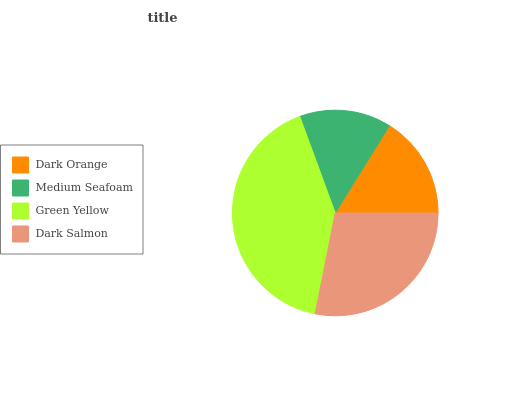Is Medium Seafoam the minimum?
Answer yes or no. Yes. Is Green Yellow the maximum?
Answer yes or no. Yes. Is Green Yellow the minimum?
Answer yes or no. No. Is Medium Seafoam the maximum?
Answer yes or no. No. Is Green Yellow greater than Medium Seafoam?
Answer yes or no. Yes. Is Medium Seafoam less than Green Yellow?
Answer yes or no. Yes. Is Medium Seafoam greater than Green Yellow?
Answer yes or no. No. Is Green Yellow less than Medium Seafoam?
Answer yes or no. No. Is Dark Salmon the high median?
Answer yes or no. Yes. Is Dark Orange the low median?
Answer yes or no. Yes. Is Medium Seafoam the high median?
Answer yes or no. No. Is Dark Salmon the low median?
Answer yes or no. No. 